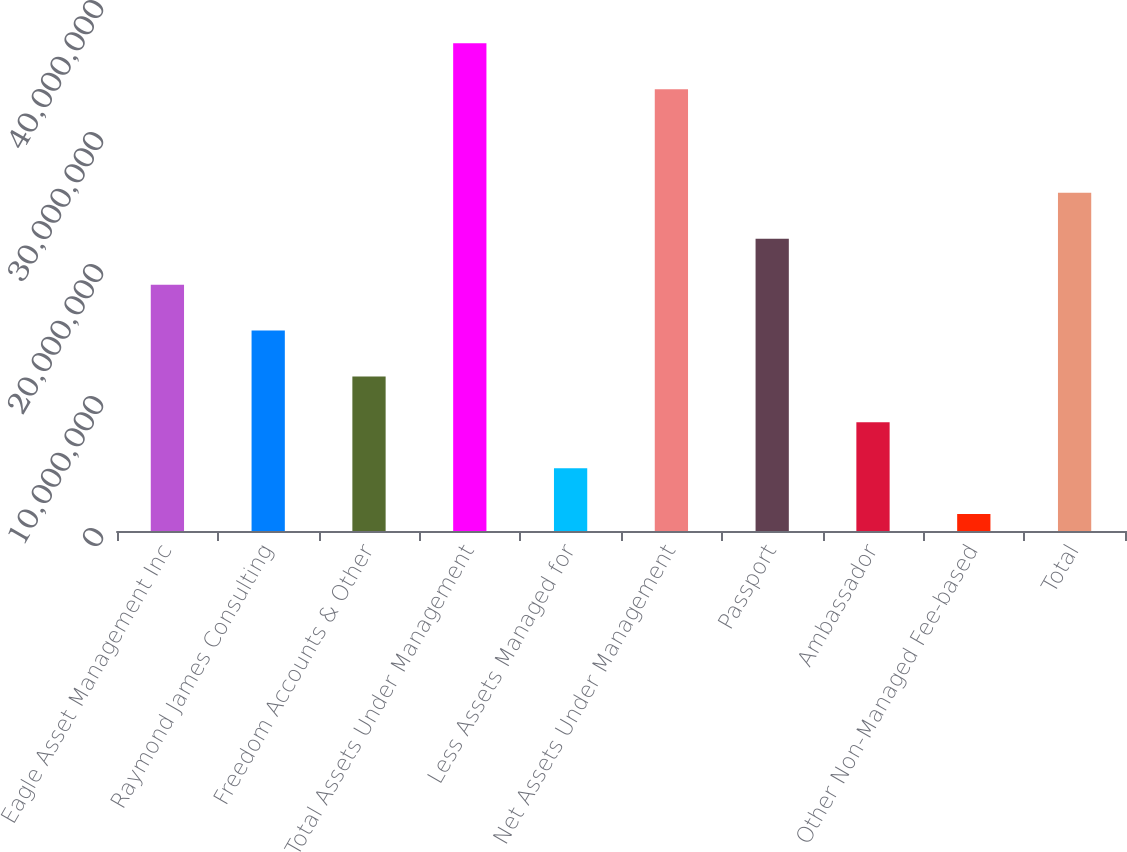Convert chart to OTSL. <chart><loc_0><loc_0><loc_500><loc_500><bar_chart><fcel>Eagle Asset Management Inc<fcel>Raymond James Consulting<fcel>Freedom Accounts & Other<fcel>Total Assets Under Management<fcel>Less Assets Managed for<fcel>Net Assets Under Management<fcel>Passport<fcel>Ambassador<fcel>Other Non-Managed Fee-based<fcel>Total<nl><fcel>1.86647e+07<fcel>1.51876e+07<fcel>1.17104e+07<fcel>3.69494e+07<fcel>4.75615e+06<fcel>3.34722e+07<fcel>2.21419e+07<fcel>8.2333e+06<fcel>1.279e+06<fcel>2.5619e+07<nl></chart> 